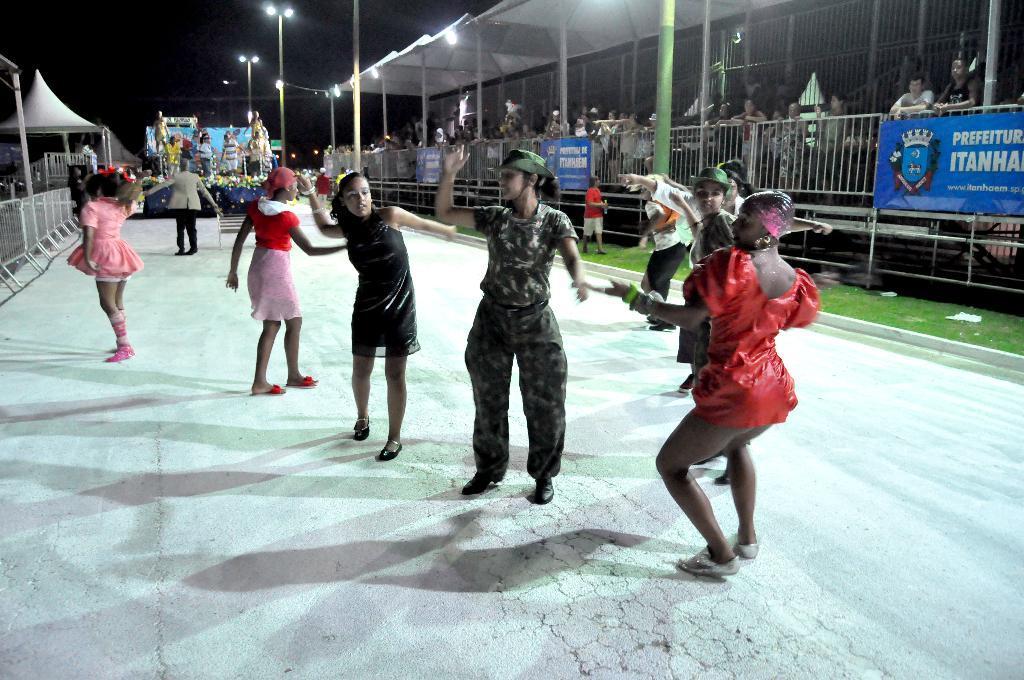How would you summarize this image in a sentence or two? In this image I can see the group of people with different color dresses. To the side I can see the railing and many boards attached to it. There are the light poles and the shed to the side. And there is a black background. 